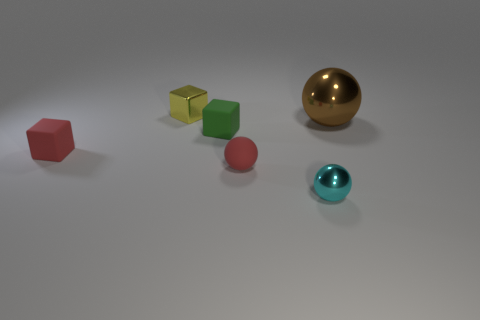Is there any other thing that has the same size as the brown metal ball?
Give a very brief answer. No. Are there fewer yellow cubes that are in front of the cyan shiny thing than tiny red rubber cubes?
Your response must be concise. Yes. What number of small spheres have the same color as the large shiny thing?
Give a very brief answer. 0. What is the sphere that is both in front of the large metal sphere and behind the cyan shiny sphere made of?
Offer a very short reply. Rubber. There is a tiny matte block that is on the right side of the tiny yellow shiny object; does it have the same color as the shiny thing left of the small metal sphere?
Your answer should be compact. No. How many red things are big objects or spheres?
Give a very brief answer. 1. Is the number of small yellow objects that are behind the metallic cube less than the number of tiny objects on the right side of the big metal ball?
Keep it short and to the point. No. Are there any matte cubes of the same size as the brown thing?
Make the answer very short. No. There is a cyan object right of the yellow block; does it have the same size as the brown metal thing?
Offer a very short reply. No. Are there more large shiny things than big green metallic balls?
Your answer should be compact. Yes. 